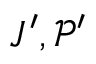Convert formula to latex. <formula><loc_0><loc_0><loc_500><loc_500>J ^ { \prime } , \mathcal { P } ^ { \prime }</formula> 